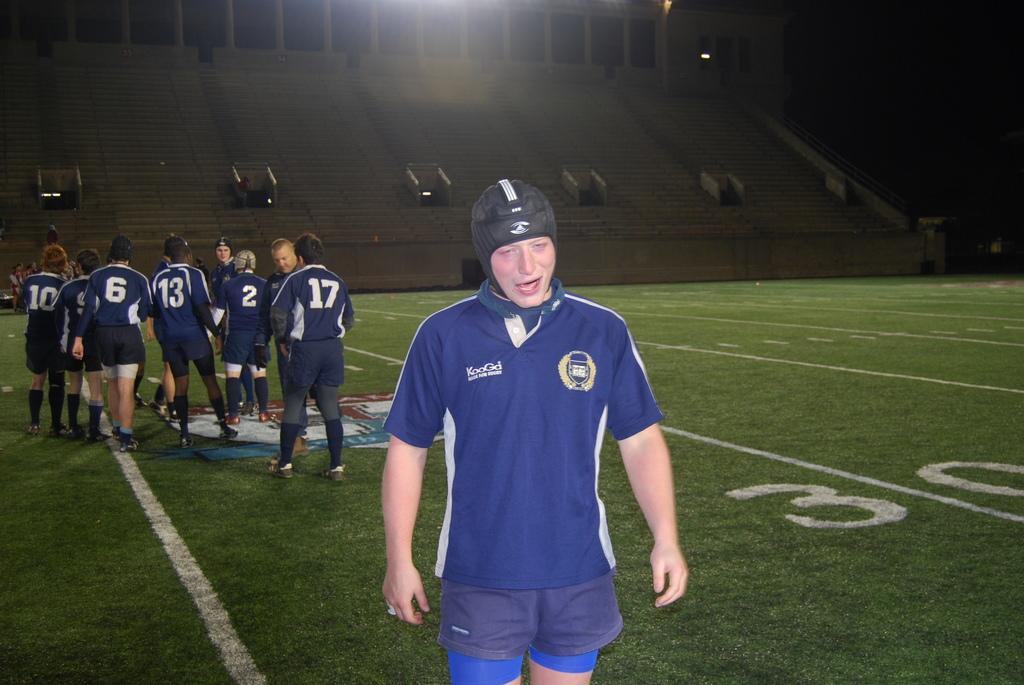What numbers are on the person's back closest the man facing you?
Keep it short and to the point. 17. 